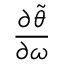Convert formula to latex. <formula><loc_0><loc_0><loc_500><loc_500>\frac { \partial \tilde { \theta } } { \partial \omega }</formula> 